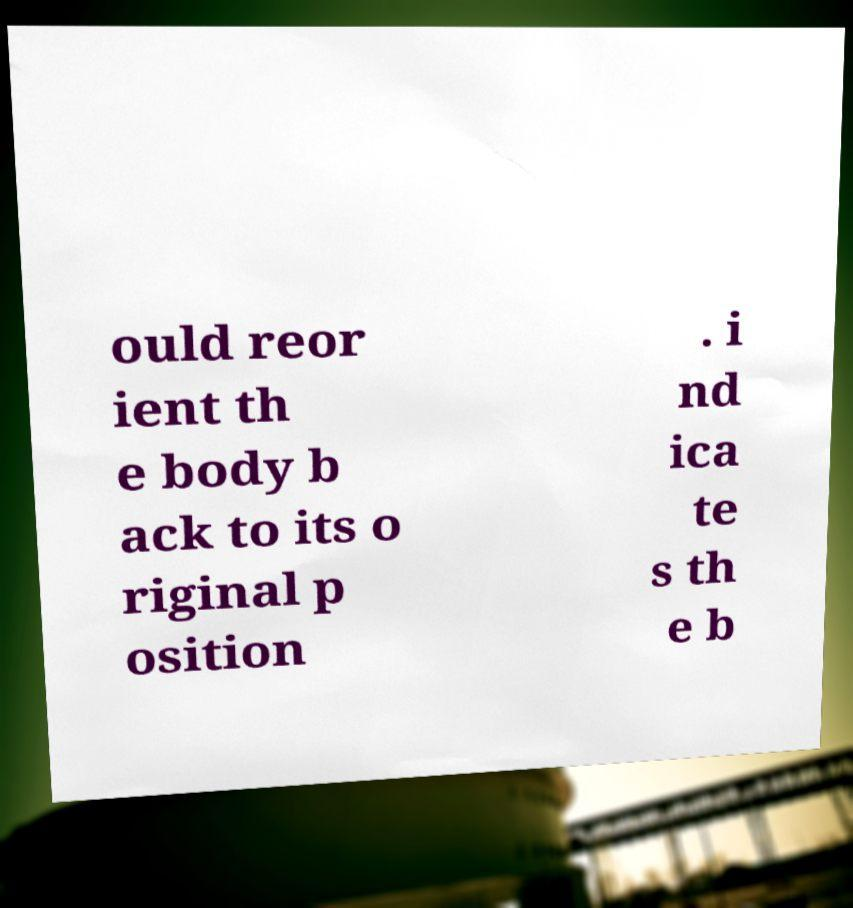Please read and relay the text visible in this image. What does it say? ould reor ient th e body b ack to its o riginal p osition . i nd ica te s th e b 